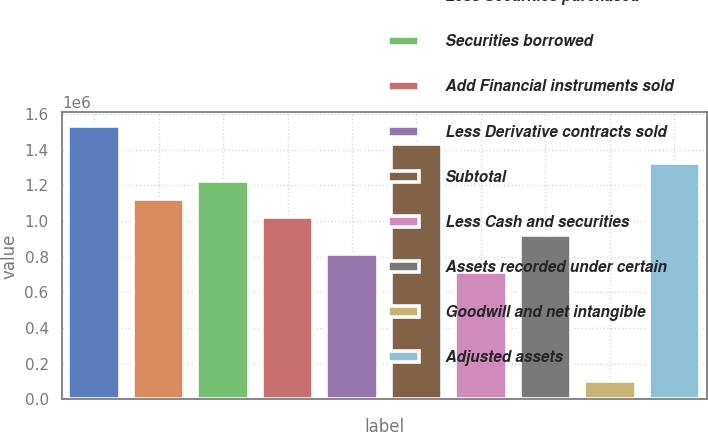<chart> <loc_0><loc_0><loc_500><loc_500><bar_chart><fcel>Total assets<fcel>Less Securities purchased<fcel>Securities borrowed<fcel>Add Financial instruments sold<fcel>Less Derivative contracts sold<fcel>Subtotal<fcel>Less Cash and securities<fcel>Assets recorded under certain<fcel>Goodwill and net intangible<fcel>Adjusted assets<nl><fcel>1.53319e+06<fcel>1.12445e+06<fcel>1.22664e+06<fcel>1.02227e+06<fcel>817900<fcel>1.43101e+06<fcel>715715<fcel>920084<fcel>102608<fcel>1.32882e+06<nl></chart> 